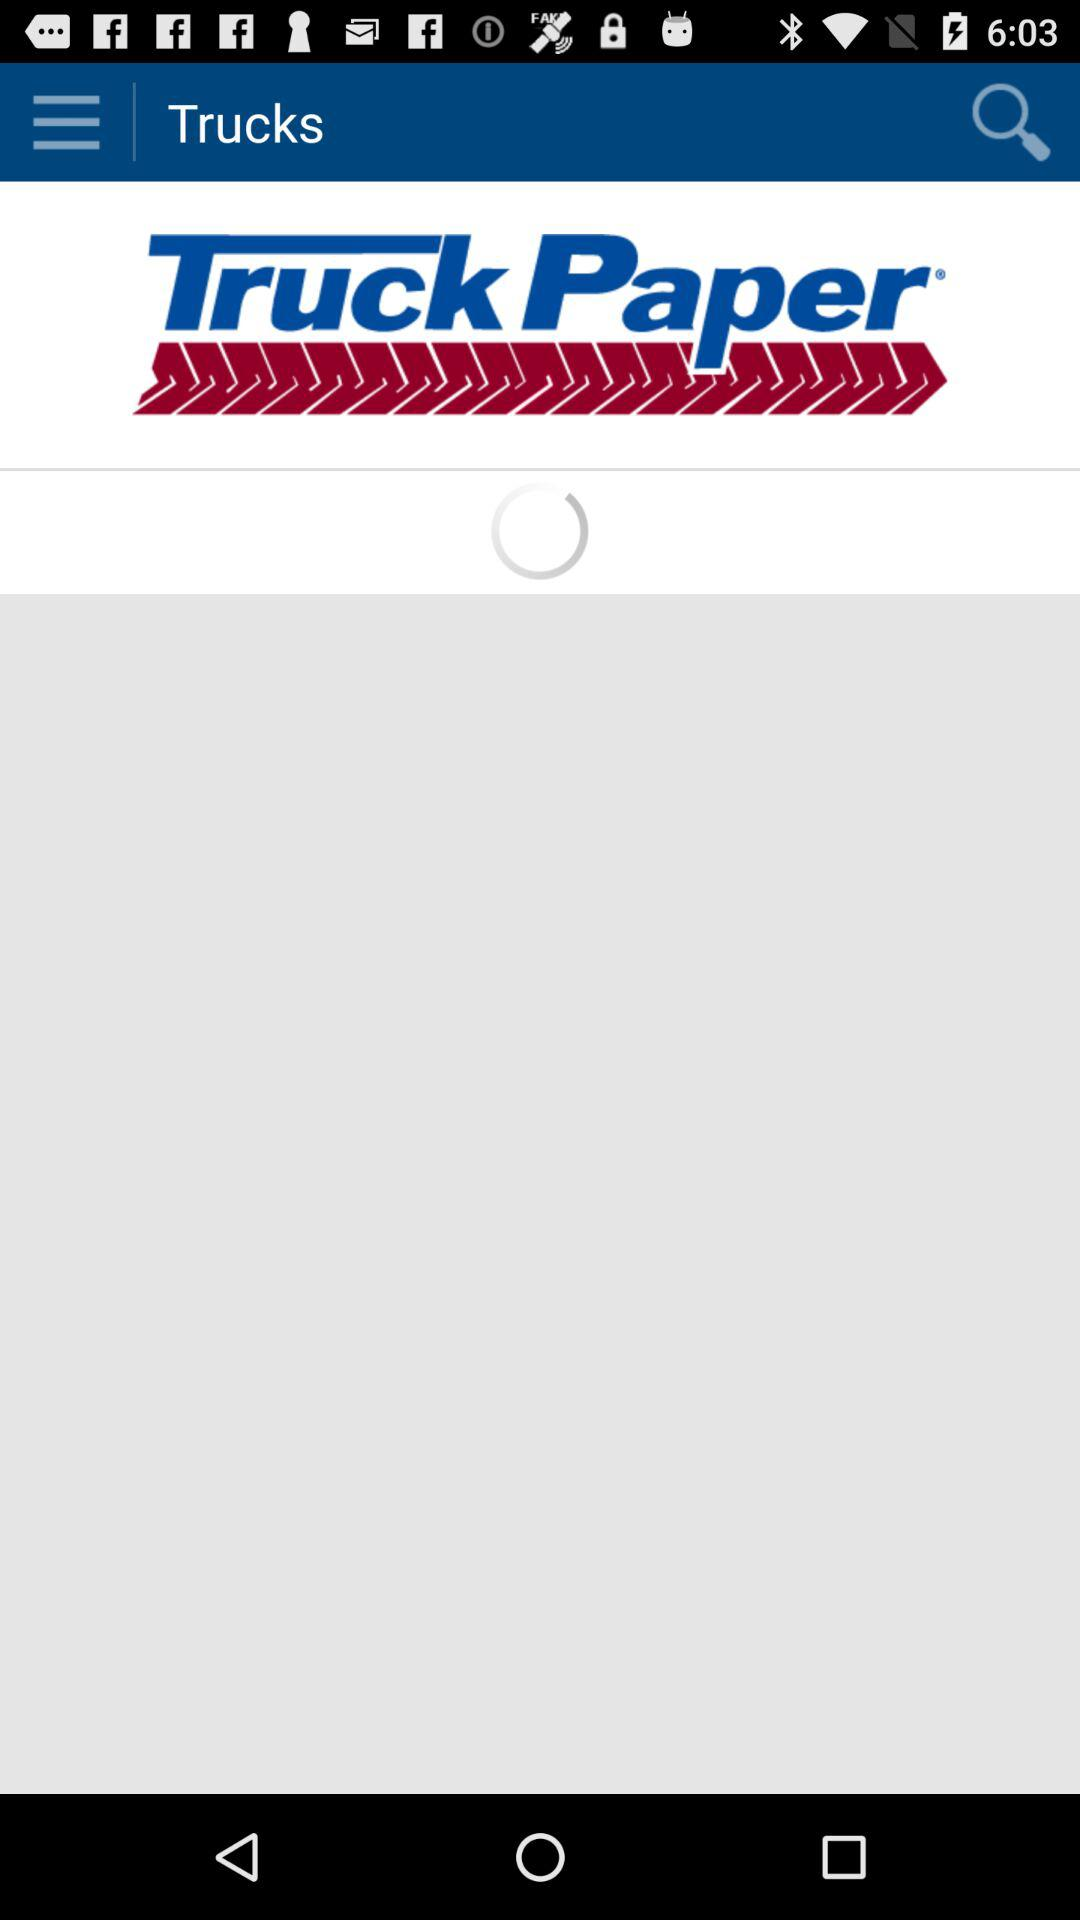What is the name of the application? The name of the application is "Truck Paper". 